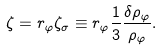Convert formula to latex. <formula><loc_0><loc_0><loc_500><loc_500>\zeta = r _ { \varphi } \zeta _ { \sigma } \equiv r _ { \varphi } \frac { 1 } { 3 } \frac { \delta \rho _ { \varphi } } { \rho _ { \varphi } } .</formula> 